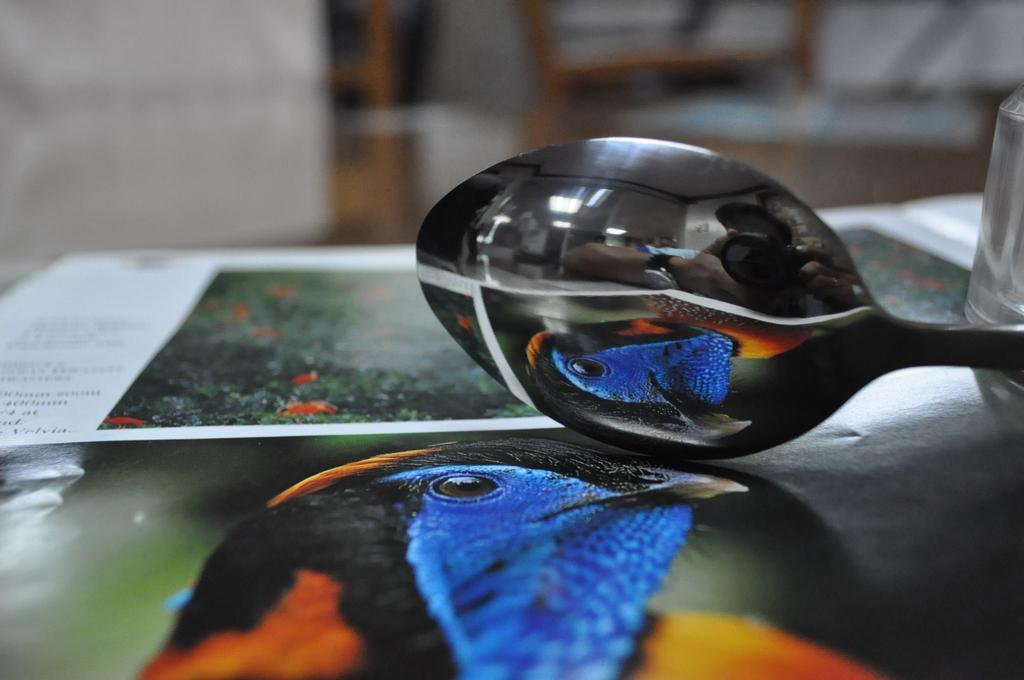In one or two sentences, can you explain what this image depicts? This picture shows a spoon and a glass and we see posters on the table. 